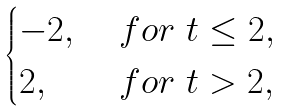<formula> <loc_0><loc_0><loc_500><loc_500>\begin{cases} - 2 , \ & f o r \ t \leq 2 , \\ 2 , \ & f o r \ t > 2 , \\ \end{cases}</formula> 